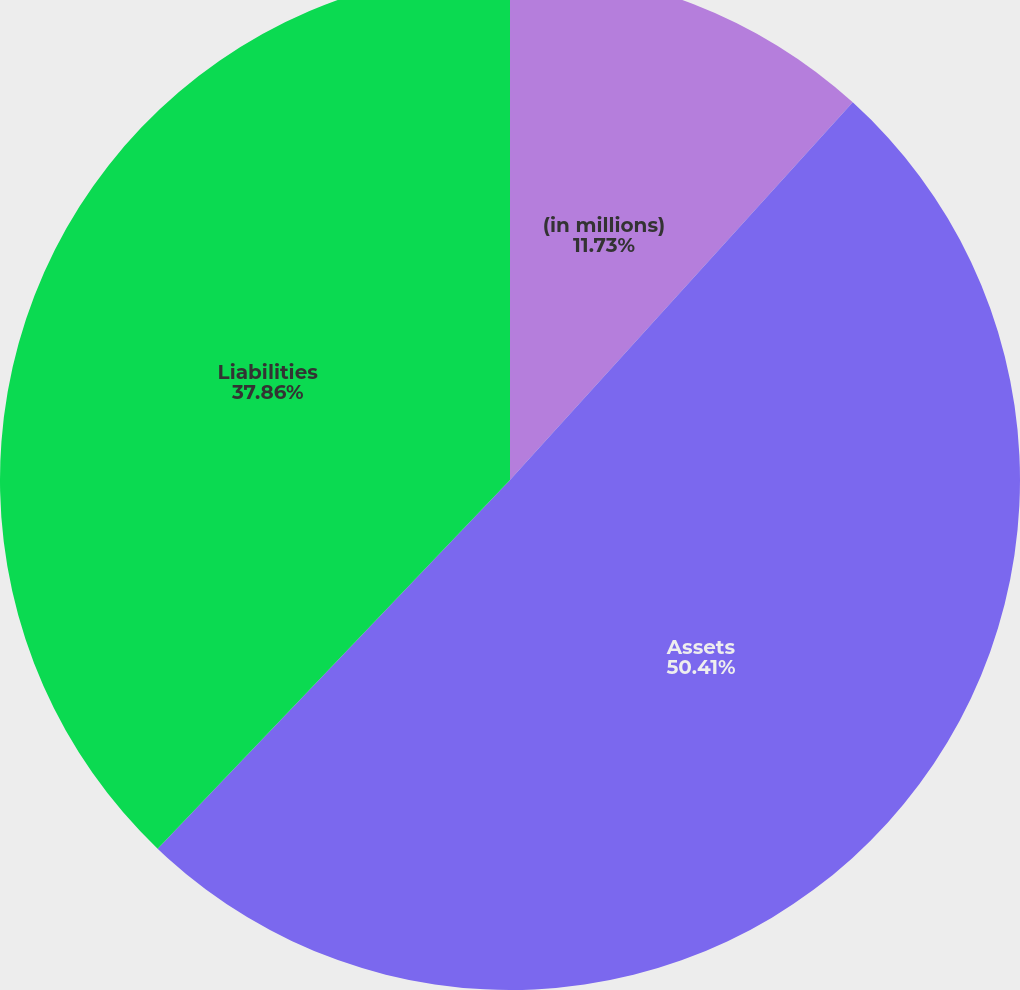<chart> <loc_0><loc_0><loc_500><loc_500><pie_chart><fcel>(in millions)<fcel>Assets<fcel>Liabilities<nl><fcel>11.73%<fcel>50.41%<fcel>37.86%<nl></chart> 